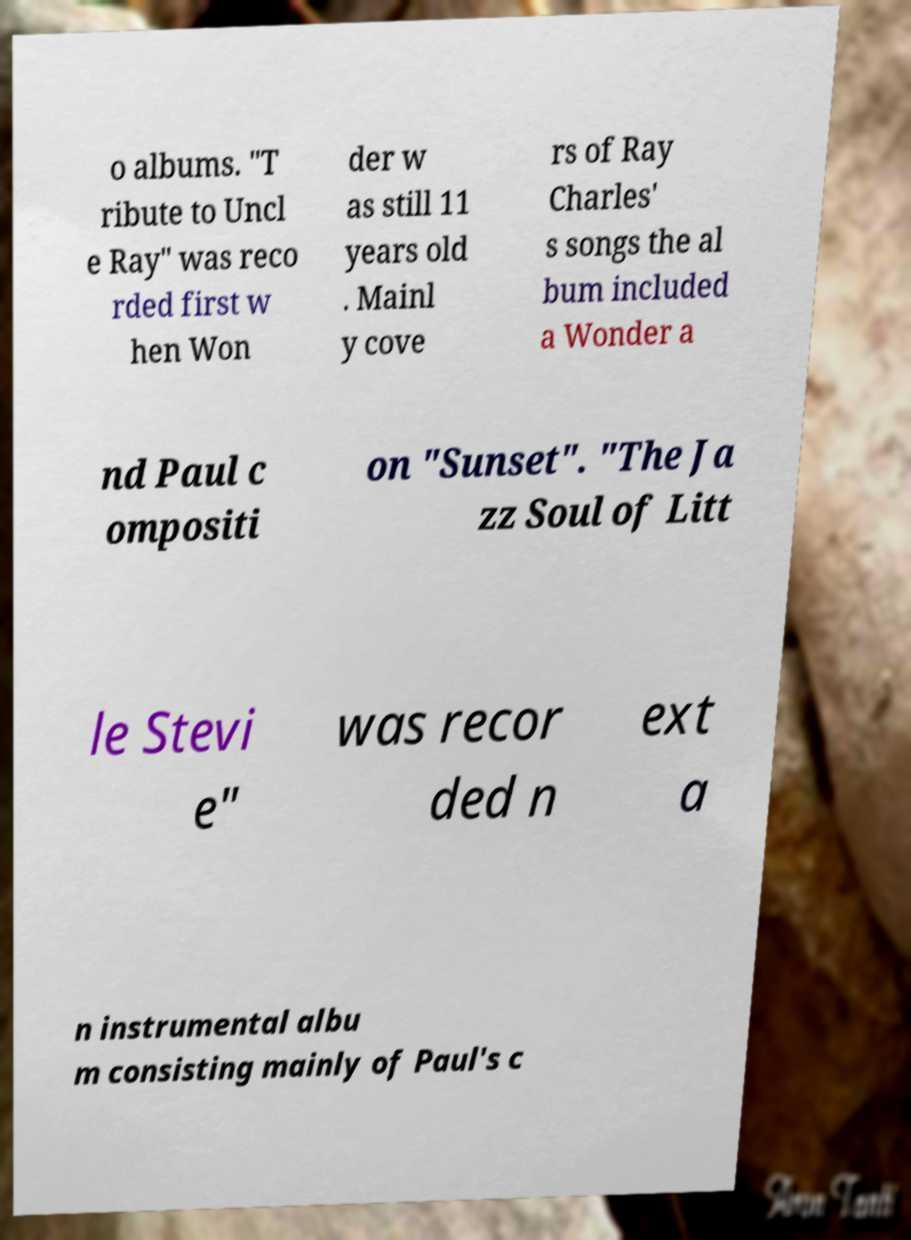For documentation purposes, I need the text within this image transcribed. Could you provide that? o albums. "T ribute to Uncl e Ray" was reco rded first w hen Won der w as still 11 years old . Mainl y cove rs of Ray Charles' s songs the al bum included a Wonder a nd Paul c ompositi on "Sunset". "The Ja zz Soul of Litt le Stevi e" was recor ded n ext a n instrumental albu m consisting mainly of Paul's c 